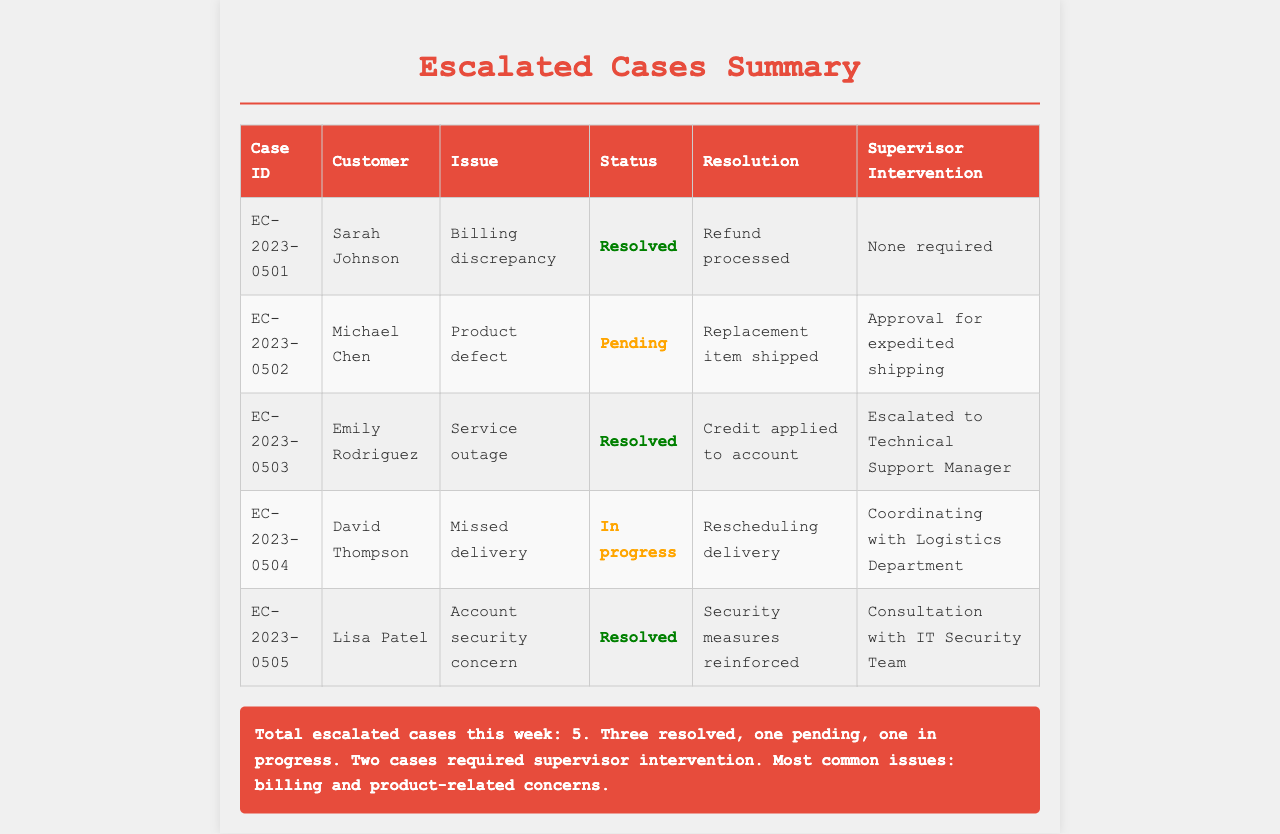What is the total number of escalated cases this week? The total number of escalated cases can be found in the summary at the bottom of the document, which states there are 5 cases.
Answer: 5 How many cases are resolved? The summary indicates that three cases have been resolved this week.
Answer: Three What is the issue listed for Sarah Johnson? Sarah Johnson's case description is specified in the table under the 'Issue' column as a billing discrepancy.
Answer: Billing discrepancy What is the resolution for the service outage case? The resolution for Emily Rodriguez's case about the service outage is detailed in the document as a credit applied to her account.
Answer: Credit applied to account Which case is currently in progress? The document specifies that the case with David Thompson regarding a missed delivery is marked as in progress.
Answer: Missed delivery How many cases required supervisor intervention? According to the summary, two cases required supervisor intervention during the past week.
Answer: Two What type of issue is the most common mentioned in the summary? The summary notes that the most common issues are billing and product-related concerns.
Answer: Billing and product-related concerns What was done regarding the account security concern? The resolution for the account security concern, associated with Lisa Patel, involved reinforcing security measures.
Answer: Security measures reinforced What was approved for expedited shipping? The table indicates that Michael Chen's case required approval for expedited shipping.
Answer: Approval for expedited shipping 